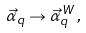<formula> <loc_0><loc_0><loc_500><loc_500>\vec { \alpha } _ { q } \to \vec { \alpha } _ { q } ^ { \, W } \, ,</formula> 